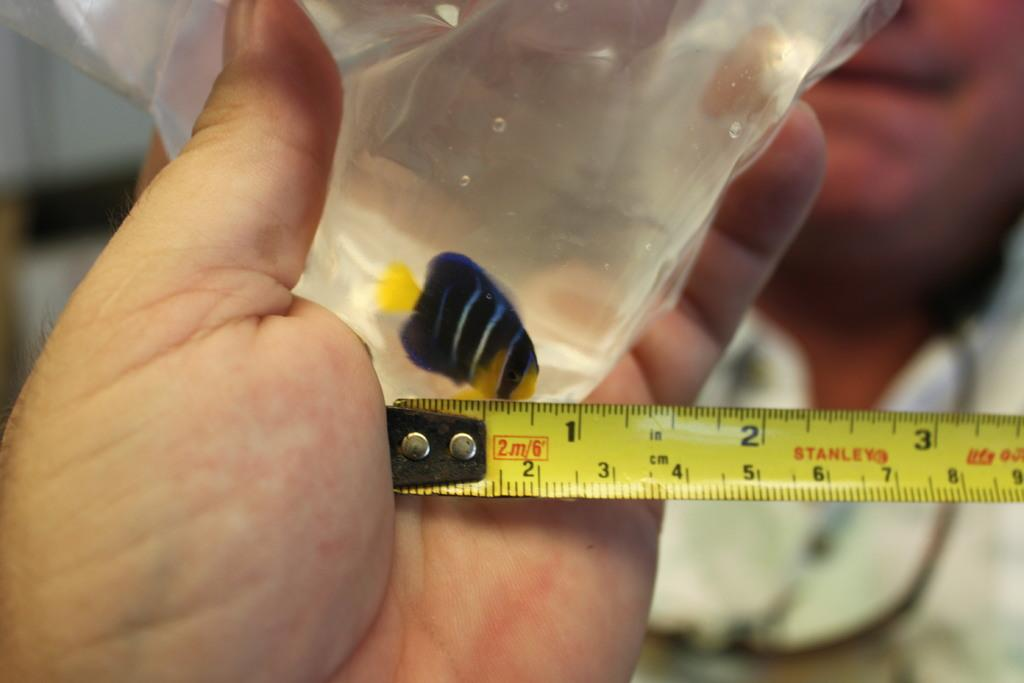Provide a one-sentence caption for the provided image. A partially extended yellow measuring tape has the name Stanley on it. 